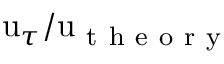<formula> <loc_0><loc_0><loc_500><loc_500>u _ { \tau } / u _ { t h e o r y }</formula> 